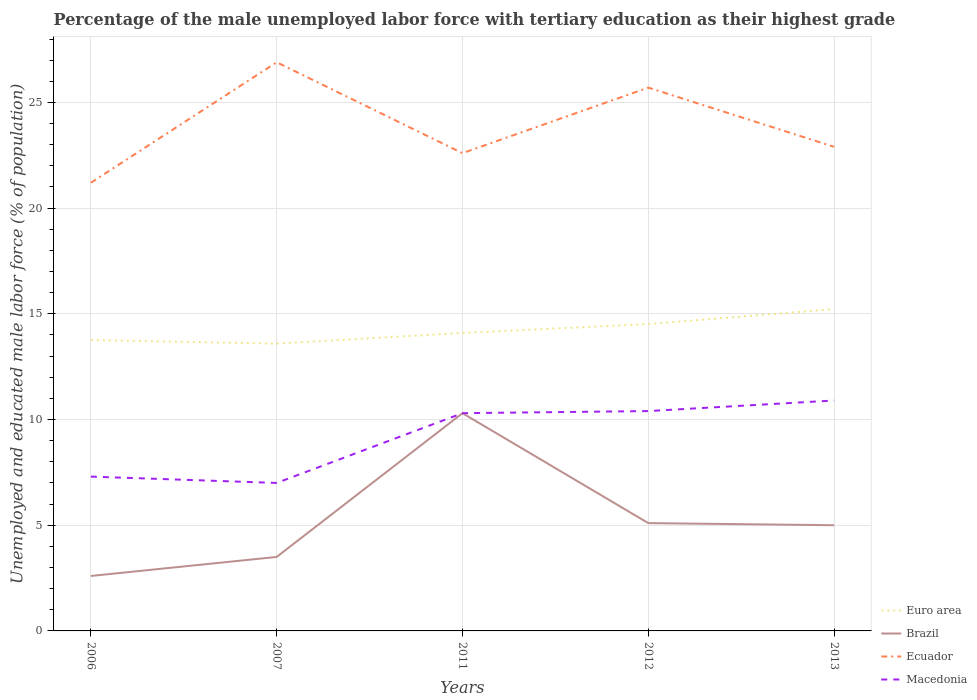How many different coloured lines are there?
Ensure brevity in your answer.  4. Does the line corresponding to Macedonia intersect with the line corresponding to Euro area?
Offer a terse response. No. Is the number of lines equal to the number of legend labels?
Provide a short and direct response. Yes. Across all years, what is the maximum percentage of the unemployed male labor force with tertiary education in Ecuador?
Ensure brevity in your answer.  21.2. What is the total percentage of the unemployed male labor force with tertiary education in Brazil in the graph?
Offer a very short reply. -7.7. What is the difference between the highest and the second highest percentage of the unemployed male labor force with tertiary education in Brazil?
Ensure brevity in your answer.  7.7. What is the difference between the highest and the lowest percentage of the unemployed male labor force with tertiary education in Euro area?
Keep it short and to the point. 2. Is the percentage of the unemployed male labor force with tertiary education in Euro area strictly greater than the percentage of the unemployed male labor force with tertiary education in Macedonia over the years?
Provide a succinct answer. No. How many years are there in the graph?
Keep it short and to the point. 5. Are the values on the major ticks of Y-axis written in scientific E-notation?
Provide a short and direct response. No. Does the graph contain grids?
Offer a very short reply. Yes. Where does the legend appear in the graph?
Ensure brevity in your answer.  Bottom right. How many legend labels are there?
Keep it short and to the point. 4. What is the title of the graph?
Your answer should be very brief. Percentage of the male unemployed labor force with tertiary education as their highest grade. What is the label or title of the Y-axis?
Offer a very short reply. Unemployed and educated male labor force (% of population). What is the Unemployed and educated male labor force (% of population) in Euro area in 2006?
Offer a very short reply. 13.76. What is the Unemployed and educated male labor force (% of population) of Brazil in 2006?
Ensure brevity in your answer.  2.6. What is the Unemployed and educated male labor force (% of population) of Ecuador in 2006?
Offer a terse response. 21.2. What is the Unemployed and educated male labor force (% of population) of Macedonia in 2006?
Ensure brevity in your answer.  7.3. What is the Unemployed and educated male labor force (% of population) in Euro area in 2007?
Your response must be concise. 13.59. What is the Unemployed and educated male labor force (% of population) in Ecuador in 2007?
Your response must be concise. 26.9. What is the Unemployed and educated male labor force (% of population) in Macedonia in 2007?
Your response must be concise. 7. What is the Unemployed and educated male labor force (% of population) of Euro area in 2011?
Ensure brevity in your answer.  14.1. What is the Unemployed and educated male labor force (% of population) of Brazil in 2011?
Keep it short and to the point. 10.3. What is the Unemployed and educated male labor force (% of population) of Ecuador in 2011?
Make the answer very short. 22.6. What is the Unemployed and educated male labor force (% of population) of Macedonia in 2011?
Keep it short and to the point. 10.3. What is the Unemployed and educated male labor force (% of population) of Euro area in 2012?
Keep it short and to the point. 14.52. What is the Unemployed and educated male labor force (% of population) in Brazil in 2012?
Give a very brief answer. 5.1. What is the Unemployed and educated male labor force (% of population) in Ecuador in 2012?
Give a very brief answer. 25.7. What is the Unemployed and educated male labor force (% of population) of Macedonia in 2012?
Offer a very short reply. 10.4. What is the Unemployed and educated male labor force (% of population) of Euro area in 2013?
Provide a short and direct response. 15.22. What is the Unemployed and educated male labor force (% of population) in Brazil in 2013?
Offer a terse response. 5. What is the Unemployed and educated male labor force (% of population) of Ecuador in 2013?
Offer a very short reply. 22.9. What is the Unemployed and educated male labor force (% of population) of Macedonia in 2013?
Offer a very short reply. 10.9. Across all years, what is the maximum Unemployed and educated male labor force (% of population) in Euro area?
Keep it short and to the point. 15.22. Across all years, what is the maximum Unemployed and educated male labor force (% of population) in Brazil?
Give a very brief answer. 10.3. Across all years, what is the maximum Unemployed and educated male labor force (% of population) of Ecuador?
Offer a very short reply. 26.9. Across all years, what is the maximum Unemployed and educated male labor force (% of population) in Macedonia?
Make the answer very short. 10.9. Across all years, what is the minimum Unemployed and educated male labor force (% of population) of Euro area?
Make the answer very short. 13.59. Across all years, what is the minimum Unemployed and educated male labor force (% of population) of Brazil?
Your response must be concise. 2.6. Across all years, what is the minimum Unemployed and educated male labor force (% of population) of Ecuador?
Keep it short and to the point. 21.2. Across all years, what is the minimum Unemployed and educated male labor force (% of population) of Macedonia?
Your answer should be very brief. 7. What is the total Unemployed and educated male labor force (% of population) in Euro area in the graph?
Your response must be concise. 71.18. What is the total Unemployed and educated male labor force (% of population) of Brazil in the graph?
Make the answer very short. 26.5. What is the total Unemployed and educated male labor force (% of population) in Ecuador in the graph?
Offer a terse response. 119.3. What is the total Unemployed and educated male labor force (% of population) of Macedonia in the graph?
Offer a very short reply. 45.9. What is the difference between the Unemployed and educated male labor force (% of population) of Euro area in 2006 and that in 2007?
Offer a very short reply. 0.17. What is the difference between the Unemployed and educated male labor force (% of population) of Macedonia in 2006 and that in 2007?
Offer a very short reply. 0.3. What is the difference between the Unemployed and educated male labor force (% of population) in Euro area in 2006 and that in 2011?
Make the answer very short. -0.34. What is the difference between the Unemployed and educated male labor force (% of population) in Ecuador in 2006 and that in 2011?
Your response must be concise. -1.4. What is the difference between the Unemployed and educated male labor force (% of population) in Euro area in 2006 and that in 2012?
Ensure brevity in your answer.  -0.76. What is the difference between the Unemployed and educated male labor force (% of population) of Brazil in 2006 and that in 2012?
Make the answer very short. -2.5. What is the difference between the Unemployed and educated male labor force (% of population) in Ecuador in 2006 and that in 2012?
Make the answer very short. -4.5. What is the difference between the Unemployed and educated male labor force (% of population) of Euro area in 2006 and that in 2013?
Make the answer very short. -1.46. What is the difference between the Unemployed and educated male labor force (% of population) of Brazil in 2006 and that in 2013?
Give a very brief answer. -2.4. What is the difference between the Unemployed and educated male labor force (% of population) in Macedonia in 2006 and that in 2013?
Offer a very short reply. -3.6. What is the difference between the Unemployed and educated male labor force (% of population) in Euro area in 2007 and that in 2011?
Ensure brevity in your answer.  -0.5. What is the difference between the Unemployed and educated male labor force (% of population) of Brazil in 2007 and that in 2011?
Offer a terse response. -6.8. What is the difference between the Unemployed and educated male labor force (% of population) in Macedonia in 2007 and that in 2011?
Provide a short and direct response. -3.3. What is the difference between the Unemployed and educated male labor force (% of population) of Euro area in 2007 and that in 2012?
Offer a terse response. -0.93. What is the difference between the Unemployed and educated male labor force (% of population) of Brazil in 2007 and that in 2012?
Give a very brief answer. -1.6. What is the difference between the Unemployed and educated male labor force (% of population) of Macedonia in 2007 and that in 2012?
Your response must be concise. -3.4. What is the difference between the Unemployed and educated male labor force (% of population) of Euro area in 2007 and that in 2013?
Your response must be concise. -1.63. What is the difference between the Unemployed and educated male labor force (% of population) in Brazil in 2007 and that in 2013?
Make the answer very short. -1.5. What is the difference between the Unemployed and educated male labor force (% of population) in Ecuador in 2007 and that in 2013?
Your response must be concise. 4. What is the difference between the Unemployed and educated male labor force (% of population) in Euro area in 2011 and that in 2012?
Provide a short and direct response. -0.42. What is the difference between the Unemployed and educated male labor force (% of population) of Ecuador in 2011 and that in 2012?
Provide a succinct answer. -3.1. What is the difference between the Unemployed and educated male labor force (% of population) of Macedonia in 2011 and that in 2012?
Offer a very short reply. -0.1. What is the difference between the Unemployed and educated male labor force (% of population) in Euro area in 2011 and that in 2013?
Give a very brief answer. -1.13. What is the difference between the Unemployed and educated male labor force (% of population) of Macedonia in 2011 and that in 2013?
Your answer should be compact. -0.6. What is the difference between the Unemployed and educated male labor force (% of population) of Euro area in 2012 and that in 2013?
Your response must be concise. -0.7. What is the difference between the Unemployed and educated male labor force (% of population) in Brazil in 2012 and that in 2013?
Provide a succinct answer. 0.1. What is the difference between the Unemployed and educated male labor force (% of population) in Macedonia in 2012 and that in 2013?
Your answer should be very brief. -0.5. What is the difference between the Unemployed and educated male labor force (% of population) in Euro area in 2006 and the Unemployed and educated male labor force (% of population) in Brazil in 2007?
Offer a very short reply. 10.26. What is the difference between the Unemployed and educated male labor force (% of population) in Euro area in 2006 and the Unemployed and educated male labor force (% of population) in Ecuador in 2007?
Your response must be concise. -13.14. What is the difference between the Unemployed and educated male labor force (% of population) of Euro area in 2006 and the Unemployed and educated male labor force (% of population) of Macedonia in 2007?
Your answer should be very brief. 6.76. What is the difference between the Unemployed and educated male labor force (% of population) of Brazil in 2006 and the Unemployed and educated male labor force (% of population) of Ecuador in 2007?
Give a very brief answer. -24.3. What is the difference between the Unemployed and educated male labor force (% of population) in Brazil in 2006 and the Unemployed and educated male labor force (% of population) in Macedonia in 2007?
Your answer should be compact. -4.4. What is the difference between the Unemployed and educated male labor force (% of population) of Ecuador in 2006 and the Unemployed and educated male labor force (% of population) of Macedonia in 2007?
Your response must be concise. 14.2. What is the difference between the Unemployed and educated male labor force (% of population) in Euro area in 2006 and the Unemployed and educated male labor force (% of population) in Brazil in 2011?
Make the answer very short. 3.46. What is the difference between the Unemployed and educated male labor force (% of population) in Euro area in 2006 and the Unemployed and educated male labor force (% of population) in Ecuador in 2011?
Offer a very short reply. -8.84. What is the difference between the Unemployed and educated male labor force (% of population) in Euro area in 2006 and the Unemployed and educated male labor force (% of population) in Macedonia in 2011?
Your answer should be very brief. 3.46. What is the difference between the Unemployed and educated male labor force (% of population) of Brazil in 2006 and the Unemployed and educated male labor force (% of population) of Macedonia in 2011?
Offer a terse response. -7.7. What is the difference between the Unemployed and educated male labor force (% of population) of Euro area in 2006 and the Unemployed and educated male labor force (% of population) of Brazil in 2012?
Your answer should be compact. 8.66. What is the difference between the Unemployed and educated male labor force (% of population) of Euro area in 2006 and the Unemployed and educated male labor force (% of population) of Ecuador in 2012?
Ensure brevity in your answer.  -11.94. What is the difference between the Unemployed and educated male labor force (% of population) of Euro area in 2006 and the Unemployed and educated male labor force (% of population) of Macedonia in 2012?
Offer a very short reply. 3.36. What is the difference between the Unemployed and educated male labor force (% of population) in Brazil in 2006 and the Unemployed and educated male labor force (% of population) in Ecuador in 2012?
Your response must be concise. -23.1. What is the difference between the Unemployed and educated male labor force (% of population) in Brazil in 2006 and the Unemployed and educated male labor force (% of population) in Macedonia in 2012?
Make the answer very short. -7.8. What is the difference between the Unemployed and educated male labor force (% of population) of Euro area in 2006 and the Unemployed and educated male labor force (% of population) of Brazil in 2013?
Give a very brief answer. 8.76. What is the difference between the Unemployed and educated male labor force (% of population) of Euro area in 2006 and the Unemployed and educated male labor force (% of population) of Ecuador in 2013?
Offer a very short reply. -9.14. What is the difference between the Unemployed and educated male labor force (% of population) in Euro area in 2006 and the Unemployed and educated male labor force (% of population) in Macedonia in 2013?
Keep it short and to the point. 2.86. What is the difference between the Unemployed and educated male labor force (% of population) in Brazil in 2006 and the Unemployed and educated male labor force (% of population) in Ecuador in 2013?
Your response must be concise. -20.3. What is the difference between the Unemployed and educated male labor force (% of population) in Euro area in 2007 and the Unemployed and educated male labor force (% of population) in Brazil in 2011?
Offer a very short reply. 3.29. What is the difference between the Unemployed and educated male labor force (% of population) in Euro area in 2007 and the Unemployed and educated male labor force (% of population) in Ecuador in 2011?
Offer a terse response. -9.01. What is the difference between the Unemployed and educated male labor force (% of population) of Euro area in 2007 and the Unemployed and educated male labor force (% of population) of Macedonia in 2011?
Keep it short and to the point. 3.29. What is the difference between the Unemployed and educated male labor force (% of population) of Brazil in 2007 and the Unemployed and educated male labor force (% of population) of Ecuador in 2011?
Keep it short and to the point. -19.1. What is the difference between the Unemployed and educated male labor force (% of population) of Euro area in 2007 and the Unemployed and educated male labor force (% of population) of Brazil in 2012?
Make the answer very short. 8.49. What is the difference between the Unemployed and educated male labor force (% of population) in Euro area in 2007 and the Unemployed and educated male labor force (% of population) in Ecuador in 2012?
Offer a terse response. -12.11. What is the difference between the Unemployed and educated male labor force (% of population) of Euro area in 2007 and the Unemployed and educated male labor force (% of population) of Macedonia in 2012?
Your response must be concise. 3.19. What is the difference between the Unemployed and educated male labor force (% of population) of Brazil in 2007 and the Unemployed and educated male labor force (% of population) of Ecuador in 2012?
Offer a very short reply. -22.2. What is the difference between the Unemployed and educated male labor force (% of population) of Euro area in 2007 and the Unemployed and educated male labor force (% of population) of Brazil in 2013?
Make the answer very short. 8.59. What is the difference between the Unemployed and educated male labor force (% of population) in Euro area in 2007 and the Unemployed and educated male labor force (% of population) in Ecuador in 2013?
Provide a succinct answer. -9.31. What is the difference between the Unemployed and educated male labor force (% of population) of Euro area in 2007 and the Unemployed and educated male labor force (% of population) of Macedonia in 2013?
Your response must be concise. 2.69. What is the difference between the Unemployed and educated male labor force (% of population) in Brazil in 2007 and the Unemployed and educated male labor force (% of population) in Ecuador in 2013?
Ensure brevity in your answer.  -19.4. What is the difference between the Unemployed and educated male labor force (% of population) in Brazil in 2007 and the Unemployed and educated male labor force (% of population) in Macedonia in 2013?
Your answer should be very brief. -7.4. What is the difference between the Unemployed and educated male labor force (% of population) of Euro area in 2011 and the Unemployed and educated male labor force (% of population) of Brazil in 2012?
Your answer should be compact. 9. What is the difference between the Unemployed and educated male labor force (% of population) in Euro area in 2011 and the Unemployed and educated male labor force (% of population) in Ecuador in 2012?
Give a very brief answer. -11.6. What is the difference between the Unemployed and educated male labor force (% of population) in Euro area in 2011 and the Unemployed and educated male labor force (% of population) in Macedonia in 2012?
Keep it short and to the point. 3.7. What is the difference between the Unemployed and educated male labor force (% of population) of Brazil in 2011 and the Unemployed and educated male labor force (% of population) of Ecuador in 2012?
Ensure brevity in your answer.  -15.4. What is the difference between the Unemployed and educated male labor force (% of population) of Brazil in 2011 and the Unemployed and educated male labor force (% of population) of Macedonia in 2012?
Give a very brief answer. -0.1. What is the difference between the Unemployed and educated male labor force (% of population) in Ecuador in 2011 and the Unemployed and educated male labor force (% of population) in Macedonia in 2012?
Keep it short and to the point. 12.2. What is the difference between the Unemployed and educated male labor force (% of population) of Euro area in 2011 and the Unemployed and educated male labor force (% of population) of Brazil in 2013?
Your response must be concise. 9.1. What is the difference between the Unemployed and educated male labor force (% of population) in Euro area in 2011 and the Unemployed and educated male labor force (% of population) in Ecuador in 2013?
Your answer should be compact. -8.8. What is the difference between the Unemployed and educated male labor force (% of population) of Euro area in 2011 and the Unemployed and educated male labor force (% of population) of Macedonia in 2013?
Your response must be concise. 3.2. What is the difference between the Unemployed and educated male labor force (% of population) in Brazil in 2011 and the Unemployed and educated male labor force (% of population) in Ecuador in 2013?
Provide a succinct answer. -12.6. What is the difference between the Unemployed and educated male labor force (% of population) of Ecuador in 2011 and the Unemployed and educated male labor force (% of population) of Macedonia in 2013?
Ensure brevity in your answer.  11.7. What is the difference between the Unemployed and educated male labor force (% of population) of Euro area in 2012 and the Unemployed and educated male labor force (% of population) of Brazil in 2013?
Ensure brevity in your answer.  9.52. What is the difference between the Unemployed and educated male labor force (% of population) in Euro area in 2012 and the Unemployed and educated male labor force (% of population) in Ecuador in 2013?
Make the answer very short. -8.38. What is the difference between the Unemployed and educated male labor force (% of population) of Euro area in 2012 and the Unemployed and educated male labor force (% of population) of Macedonia in 2013?
Your answer should be compact. 3.62. What is the difference between the Unemployed and educated male labor force (% of population) in Brazil in 2012 and the Unemployed and educated male labor force (% of population) in Ecuador in 2013?
Offer a very short reply. -17.8. What is the difference between the Unemployed and educated male labor force (% of population) of Brazil in 2012 and the Unemployed and educated male labor force (% of population) of Macedonia in 2013?
Give a very brief answer. -5.8. What is the average Unemployed and educated male labor force (% of population) of Euro area per year?
Offer a very short reply. 14.24. What is the average Unemployed and educated male labor force (% of population) in Brazil per year?
Provide a short and direct response. 5.3. What is the average Unemployed and educated male labor force (% of population) in Ecuador per year?
Your answer should be very brief. 23.86. What is the average Unemployed and educated male labor force (% of population) in Macedonia per year?
Provide a short and direct response. 9.18. In the year 2006, what is the difference between the Unemployed and educated male labor force (% of population) of Euro area and Unemployed and educated male labor force (% of population) of Brazil?
Offer a very short reply. 11.16. In the year 2006, what is the difference between the Unemployed and educated male labor force (% of population) in Euro area and Unemployed and educated male labor force (% of population) in Ecuador?
Your response must be concise. -7.44. In the year 2006, what is the difference between the Unemployed and educated male labor force (% of population) in Euro area and Unemployed and educated male labor force (% of population) in Macedonia?
Offer a very short reply. 6.46. In the year 2006, what is the difference between the Unemployed and educated male labor force (% of population) in Brazil and Unemployed and educated male labor force (% of population) in Ecuador?
Provide a succinct answer. -18.6. In the year 2007, what is the difference between the Unemployed and educated male labor force (% of population) in Euro area and Unemployed and educated male labor force (% of population) in Brazil?
Offer a terse response. 10.09. In the year 2007, what is the difference between the Unemployed and educated male labor force (% of population) of Euro area and Unemployed and educated male labor force (% of population) of Ecuador?
Ensure brevity in your answer.  -13.31. In the year 2007, what is the difference between the Unemployed and educated male labor force (% of population) of Euro area and Unemployed and educated male labor force (% of population) of Macedonia?
Ensure brevity in your answer.  6.59. In the year 2007, what is the difference between the Unemployed and educated male labor force (% of population) in Brazil and Unemployed and educated male labor force (% of population) in Ecuador?
Your answer should be compact. -23.4. In the year 2007, what is the difference between the Unemployed and educated male labor force (% of population) of Ecuador and Unemployed and educated male labor force (% of population) of Macedonia?
Ensure brevity in your answer.  19.9. In the year 2011, what is the difference between the Unemployed and educated male labor force (% of population) of Euro area and Unemployed and educated male labor force (% of population) of Brazil?
Your response must be concise. 3.8. In the year 2011, what is the difference between the Unemployed and educated male labor force (% of population) of Euro area and Unemployed and educated male labor force (% of population) of Ecuador?
Give a very brief answer. -8.5. In the year 2011, what is the difference between the Unemployed and educated male labor force (% of population) of Euro area and Unemployed and educated male labor force (% of population) of Macedonia?
Ensure brevity in your answer.  3.8. In the year 2011, what is the difference between the Unemployed and educated male labor force (% of population) in Brazil and Unemployed and educated male labor force (% of population) in Macedonia?
Give a very brief answer. 0. In the year 2012, what is the difference between the Unemployed and educated male labor force (% of population) in Euro area and Unemployed and educated male labor force (% of population) in Brazil?
Offer a terse response. 9.42. In the year 2012, what is the difference between the Unemployed and educated male labor force (% of population) of Euro area and Unemployed and educated male labor force (% of population) of Ecuador?
Make the answer very short. -11.18. In the year 2012, what is the difference between the Unemployed and educated male labor force (% of population) in Euro area and Unemployed and educated male labor force (% of population) in Macedonia?
Ensure brevity in your answer.  4.12. In the year 2012, what is the difference between the Unemployed and educated male labor force (% of population) in Brazil and Unemployed and educated male labor force (% of population) in Ecuador?
Ensure brevity in your answer.  -20.6. In the year 2012, what is the difference between the Unemployed and educated male labor force (% of population) in Brazil and Unemployed and educated male labor force (% of population) in Macedonia?
Your response must be concise. -5.3. In the year 2013, what is the difference between the Unemployed and educated male labor force (% of population) of Euro area and Unemployed and educated male labor force (% of population) of Brazil?
Your answer should be compact. 10.22. In the year 2013, what is the difference between the Unemployed and educated male labor force (% of population) in Euro area and Unemployed and educated male labor force (% of population) in Ecuador?
Your answer should be compact. -7.68. In the year 2013, what is the difference between the Unemployed and educated male labor force (% of population) in Euro area and Unemployed and educated male labor force (% of population) in Macedonia?
Provide a succinct answer. 4.32. In the year 2013, what is the difference between the Unemployed and educated male labor force (% of population) in Brazil and Unemployed and educated male labor force (% of population) in Ecuador?
Make the answer very short. -17.9. In the year 2013, what is the difference between the Unemployed and educated male labor force (% of population) of Ecuador and Unemployed and educated male labor force (% of population) of Macedonia?
Give a very brief answer. 12. What is the ratio of the Unemployed and educated male labor force (% of population) in Euro area in 2006 to that in 2007?
Offer a very short reply. 1.01. What is the ratio of the Unemployed and educated male labor force (% of population) of Brazil in 2006 to that in 2007?
Your answer should be compact. 0.74. What is the ratio of the Unemployed and educated male labor force (% of population) in Ecuador in 2006 to that in 2007?
Provide a short and direct response. 0.79. What is the ratio of the Unemployed and educated male labor force (% of population) in Macedonia in 2006 to that in 2007?
Make the answer very short. 1.04. What is the ratio of the Unemployed and educated male labor force (% of population) of Euro area in 2006 to that in 2011?
Offer a terse response. 0.98. What is the ratio of the Unemployed and educated male labor force (% of population) of Brazil in 2006 to that in 2011?
Make the answer very short. 0.25. What is the ratio of the Unemployed and educated male labor force (% of population) in Ecuador in 2006 to that in 2011?
Give a very brief answer. 0.94. What is the ratio of the Unemployed and educated male labor force (% of population) of Macedonia in 2006 to that in 2011?
Give a very brief answer. 0.71. What is the ratio of the Unemployed and educated male labor force (% of population) in Euro area in 2006 to that in 2012?
Your answer should be compact. 0.95. What is the ratio of the Unemployed and educated male labor force (% of population) in Brazil in 2006 to that in 2012?
Provide a short and direct response. 0.51. What is the ratio of the Unemployed and educated male labor force (% of population) of Ecuador in 2006 to that in 2012?
Your answer should be compact. 0.82. What is the ratio of the Unemployed and educated male labor force (% of population) in Macedonia in 2006 to that in 2012?
Offer a terse response. 0.7. What is the ratio of the Unemployed and educated male labor force (% of population) of Euro area in 2006 to that in 2013?
Provide a short and direct response. 0.9. What is the ratio of the Unemployed and educated male labor force (% of population) in Brazil in 2006 to that in 2013?
Provide a succinct answer. 0.52. What is the ratio of the Unemployed and educated male labor force (% of population) in Ecuador in 2006 to that in 2013?
Keep it short and to the point. 0.93. What is the ratio of the Unemployed and educated male labor force (% of population) in Macedonia in 2006 to that in 2013?
Offer a very short reply. 0.67. What is the ratio of the Unemployed and educated male labor force (% of population) in Euro area in 2007 to that in 2011?
Make the answer very short. 0.96. What is the ratio of the Unemployed and educated male labor force (% of population) in Brazil in 2007 to that in 2011?
Your answer should be very brief. 0.34. What is the ratio of the Unemployed and educated male labor force (% of population) of Ecuador in 2007 to that in 2011?
Offer a very short reply. 1.19. What is the ratio of the Unemployed and educated male labor force (% of population) in Macedonia in 2007 to that in 2011?
Your answer should be very brief. 0.68. What is the ratio of the Unemployed and educated male labor force (% of population) of Euro area in 2007 to that in 2012?
Ensure brevity in your answer.  0.94. What is the ratio of the Unemployed and educated male labor force (% of population) in Brazil in 2007 to that in 2012?
Provide a succinct answer. 0.69. What is the ratio of the Unemployed and educated male labor force (% of population) of Ecuador in 2007 to that in 2012?
Provide a succinct answer. 1.05. What is the ratio of the Unemployed and educated male labor force (% of population) in Macedonia in 2007 to that in 2012?
Keep it short and to the point. 0.67. What is the ratio of the Unemployed and educated male labor force (% of population) in Euro area in 2007 to that in 2013?
Offer a terse response. 0.89. What is the ratio of the Unemployed and educated male labor force (% of population) in Ecuador in 2007 to that in 2013?
Give a very brief answer. 1.17. What is the ratio of the Unemployed and educated male labor force (% of population) of Macedonia in 2007 to that in 2013?
Your response must be concise. 0.64. What is the ratio of the Unemployed and educated male labor force (% of population) of Euro area in 2011 to that in 2012?
Provide a succinct answer. 0.97. What is the ratio of the Unemployed and educated male labor force (% of population) in Brazil in 2011 to that in 2012?
Offer a very short reply. 2.02. What is the ratio of the Unemployed and educated male labor force (% of population) in Ecuador in 2011 to that in 2012?
Ensure brevity in your answer.  0.88. What is the ratio of the Unemployed and educated male labor force (% of population) of Euro area in 2011 to that in 2013?
Offer a very short reply. 0.93. What is the ratio of the Unemployed and educated male labor force (% of population) in Brazil in 2011 to that in 2013?
Your response must be concise. 2.06. What is the ratio of the Unemployed and educated male labor force (% of population) in Ecuador in 2011 to that in 2013?
Your answer should be compact. 0.99. What is the ratio of the Unemployed and educated male labor force (% of population) in Macedonia in 2011 to that in 2013?
Your response must be concise. 0.94. What is the ratio of the Unemployed and educated male labor force (% of population) of Euro area in 2012 to that in 2013?
Ensure brevity in your answer.  0.95. What is the ratio of the Unemployed and educated male labor force (% of population) in Brazil in 2012 to that in 2013?
Your response must be concise. 1.02. What is the ratio of the Unemployed and educated male labor force (% of population) in Ecuador in 2012 to that in 2013?
Give a very brief answer. 1.12. What is the ratio of the Unemployed and educated male labor force (% of population) of Macedonia in 2012 to that in 2013?
Offer a terse response. 0.95. What is the difference between the highest and the second highest Unemployed and educated male labor force (% of population) of Euro area?
Your answer should be very brief. 0.7. What is the difference between the highest and the lowest Unemployed and educated male labor force (% of population) of Euro area?
Give a very brief answer. 1.63. What is the difference between the highest and the lowest Unemployed and educated male labor force (% of population) in Brazil?
Your answer should be compact. 7.7. What is the difference between the highest and the lowest Unemployed and educated male labor force (% of population) of Ecuador?
Your answer should be very brief. 5.7. What is the difference between the highest and the lowest Unemployed and educated male labor force (% of population) in Macedonia?
Your answer should be compact. 3.9. 